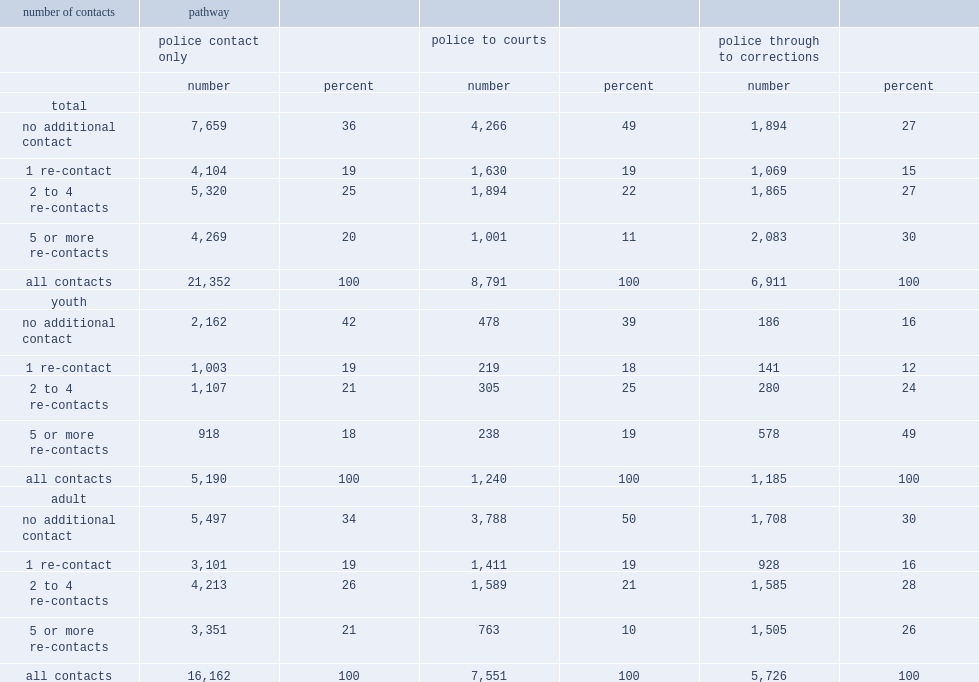Of the 6,900 people whose pathway took them through to correctional services,what's the percentage of those had a re-contact with police for a new offence after the completion of their first pathway. 73. Of people whose first contact ended in the court systemwhat's the percentage of those came back into contact with police for a new offence. 51. Of youth whose first contact ended in the court system,what's the percentage of those came back into contact with police for a new offence. 61. Of the youth whose pathway took them through to correctional services,what's the percentage of those had a re-contact with police for a new offence after the completion of their first pathway. 84. ,what's the percentage of those had 5 or more re-contacts with the system. 11.0. Of people whose first pathway ended in courts or corrections to have 5 or more re-contacts with police following their first contact.,what's the coefficient relationship between youth and adult. 1.9. Of youth who completed their first pathway in the court system ,what's the percentage of those had 5 or more re-contacts with police by the end of the study period. 19.0. Of youth who had contact with corrections,what's the percentage of those who had 5 or more re-contacts with police. 49.0. 